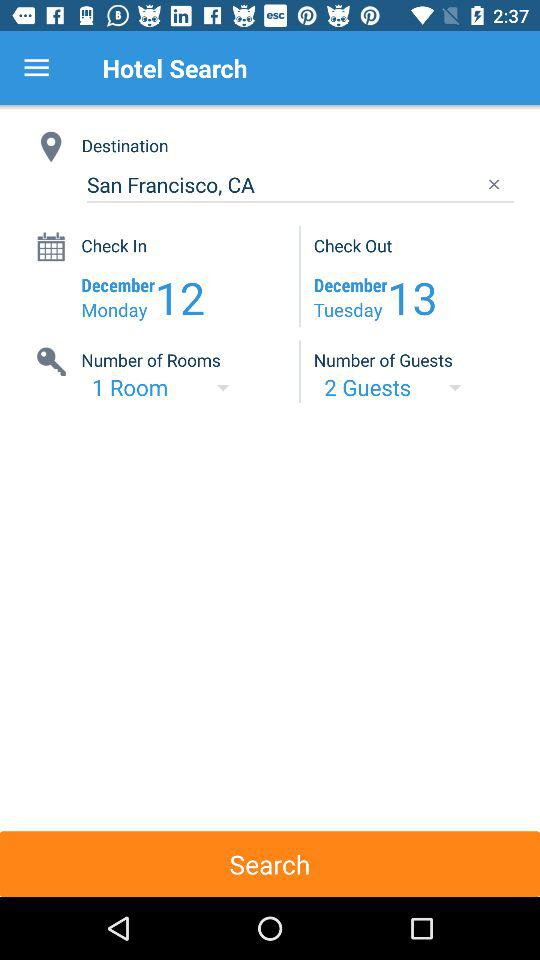How many more days are between the check in and check out dates?
Answer the question using a single word or phrase. 1 